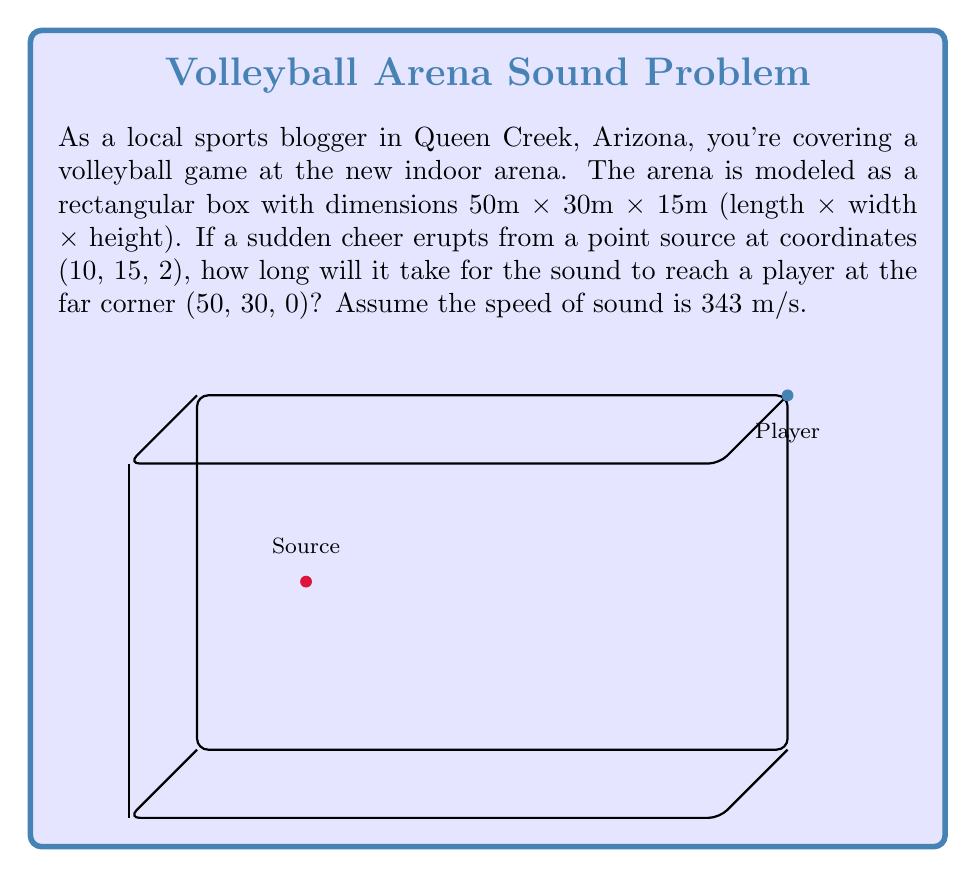Show me your answer to this math problem. To solve this problem, we need to use the wave equation for sound propagation in three dimensions. However, since we're only interested in the time it takes for the sound to reach the player, we can simplify this to a distance calculation problem.

Step 1: Calculate the distance between the source and the player.
We can use the three-dimensional distance formula:

$$d = \sqrt{(x_2-x_1)^2 + (y_2-y_1)^2 + (z_2-z_1)^2}$$

Where (x₁, y₁, z₁) is the source (10, 15, 2) and (x₂, y₂, z₂) is the player's position (50, 30, 0).

$$d = \sqrt{(50-10)^2 + (30-15)^2 + (0-2)^2}$$
$$d = \sqrt{40^2 + 15^2 + (-2)^2}$$
$$d = \sqrt{1600 + 225 + 4}$$
$$d = \sqrt{1829} \approx 42.77 \text{ meters}$$

Step 2: Calculate the time using the speed formula.
The formula for speed is:

$$\text{speed} = \frac{\text{distance}}{\text{time}}$$

Rearranging this for time:

$$\text{time} = \frac{\text{distance}}{\text{speed}}$$

Plugging in our values:

$$t = \frac{42.77 \text{ m}}{343 \text{ m/s}} \approx 0.1246 \text{ seconds}$$

Therefore, it will take approximately 0.1246 seconds for the sound to reach the player.
Answer: 0.1246 seconds 